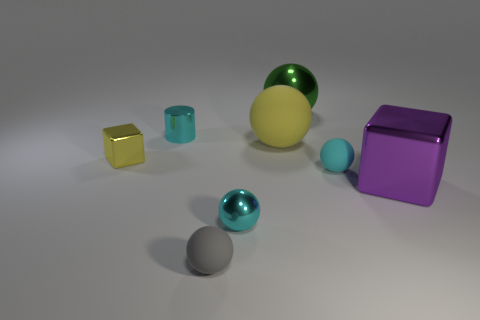How many other things are there of the same size as the green shiny sphere?
Ensure brevity in your answer.  2. There is a small matte object in front of the cyan metal object in front of the cube left of the gray matte sphere; what color is it?
Your answer should be compact. Gray. How many other things are there of the same shape as the small gray object?
Your answer should be compact. 4. There is a cyan shiny object behind the large purple metal object; what is its shape?
Give a very brief answer. Cylinder. There is a block right of the green thing; is there a green thing that is on the right side of it?
Your response must be concise. No. There is a shiny object that is to the right of the tiny cylinder and behind the tiny cyan rubber object; what color is it?
Ensure brevity in your answer.  Green. There is a cyan ball that is behind the metal cube that is in front of the tiny yellow shiny block; are there any tiny things left of it?
Offer a very short reply. Yes. There is a purple metal thing that is the same shape as the tiny yellow object; what is its size?
Make the answer very short. Large. Is there any other thing that has the same material as the tiny yellow object?
Keep it short and to the point. Yes. Are any large blue matte cylinders visible?
Offer a terse response. No. 